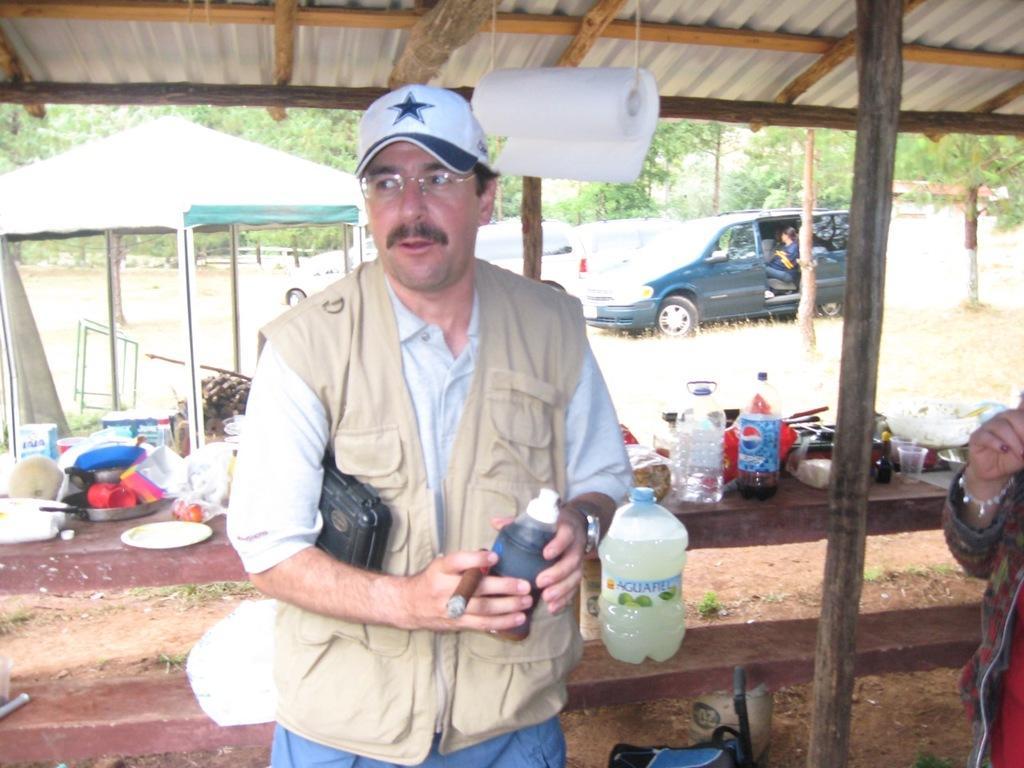Please provide a concise description of this image. In this image there is a person wearing cap holding bottle and smoke in his hands and at the left side of the image there are dishes and at the right side of the image there is a vehicle 